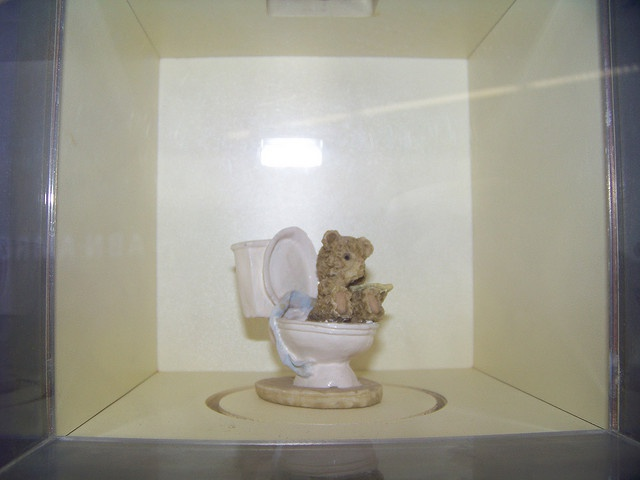Describe the objects in this image and their specific colors. I can see toilet in gray, darkgray, and lightgray tones and teddy bear in gray tones in this image. 